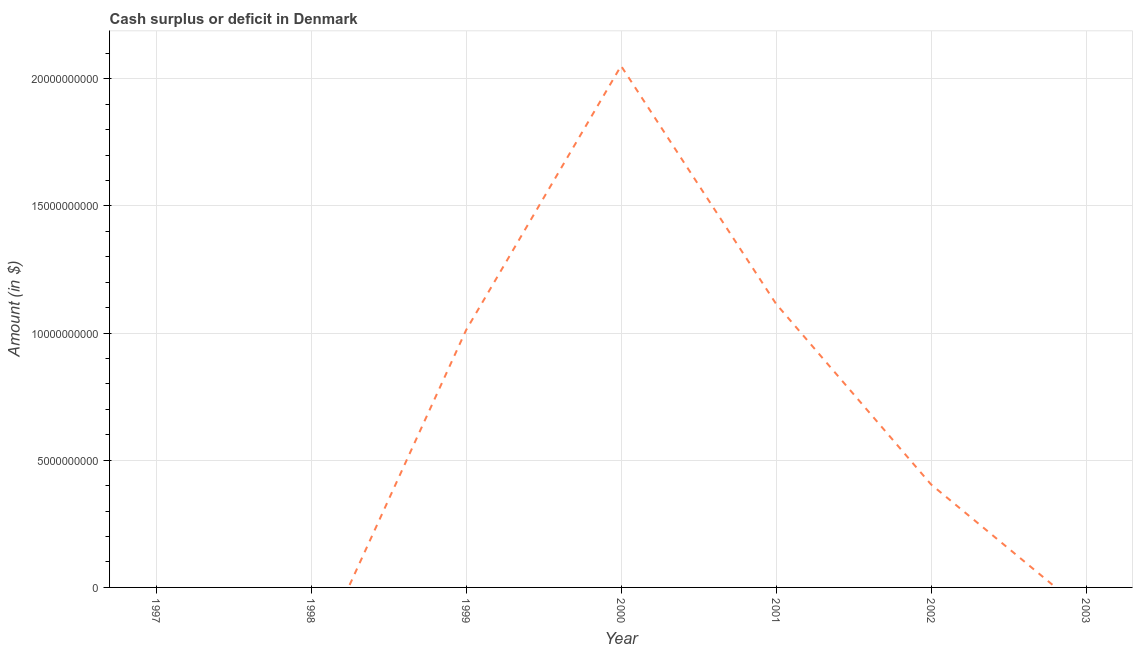What is the cash surplus or deficit in 1999?
Provide a succinct answer. 1.01e+1. Across all years, what is the maximum cash surplus or deficit?
Your answer should be compact. 2.05e+1. What is the sum of the cash surplus or deficit?
Your answer should be compact. 4.58e+1. What is the difference between the cash surplus or deficit in 1999 and 2000?
Ensure brevity in your answer.  -1.04e+1. What is the average cash surplus or deficit per year?
Provide a short and direct response. 6.55e+09. What is the median cash surplus or deficit?
Keep it short and to the point. 4.05e+09. What is the ratio of the cash surplus or deficit in 1999 to that in 2001?
Ensure brevity in your answer.  0.91. What is the difference between the highest and the second highest cash surplus or deficit?
Your response must be concise. 9.36e+09. Is the sum of the cash surplus or deficit in 1999 and 2002 greater than the maximum cash surplus or deficit across all years?
Make the answer very short. No. What is the difference between the highest and the lowest cash surplus or deficit?
Offer a terse response. 2.05e+1. In how many years, is the cash surplus or deficit greater than the average cash surplus or deficit taken over all years?
Provide a short and direct response. 3. Does the cash surplus or deficit monotonically increase over the years?
Your answer should be compact. No. How many lines are there?
Offer a terse response. 1. Are the values on the major ticks of Y-axis written in scientific E-notation?
Your answer should be very brief. No. Does the graph contain any zero values?
Provide a short and direct response. Yes. Does the graph contain grids?
Offer a terse response. Yes. What is the title of the graph?
Your answer should be very brief. Cash surplus or deficit in Denmark. What is the label or title of the Y-axis?
Your answer should be compact. Amount (in $). What is the Amount (in $) in 1999?
Provide a short and direct response. 1.01e+1. What is the Amount (in $) of 2000?
Offer a terse response. 2.05e+1. What is the Amount (in $) of 2001?
Keep it short and to the point. 1.12e+1. What is the Amount (in $) in 2002?
Offer a terse response. 4.05e+09. What is the difference between the Amount (in $) in 1999 and 2000?
Make the answer very short. -1.04e+1. What is the difference between the Amount (in $) in 1999 and 2001?
Your answer should be compact. -1.04e+09. What is the difference between the Amount (in $) in 1999 and 2002?
Provide a short and direct response. 6.07e+09. What is the difference between the Amount (in $) in 2000 and 2001?
Your answer should be compact. 9.36e+09. What is the difference between the Amount (in $) in 2000 and 2002?
Your response must be concise. 1.65e+1. What is the difference between the Amount (in $) in 2001 and 2002?
Keep it short and to the point. 7.10e+09. What is the ratio of the Amount (in $) in 1999 to that in 2000?
Make the answer very short. 0.49. What is the ratio of the Amount (in $) in 1999 to that in 2001?
Your answer should be very brief. 0.91. What is the ratio of the Amount (in $) in 1999 to that in 2002?
Your answer should be compact. 2.5. What is the ratio of the Amount (in $) in 2000 to that in 2001?
Provide a short and direct response. 1.84. What is the ratio of the Amount (in $) in 2000 to that in 2002?
Provide a succinct answer. 5.06. What is the ratio of the Amount (in $) in 2001 to that in 2002?
Ensure brevity in your answer.  2.75. 